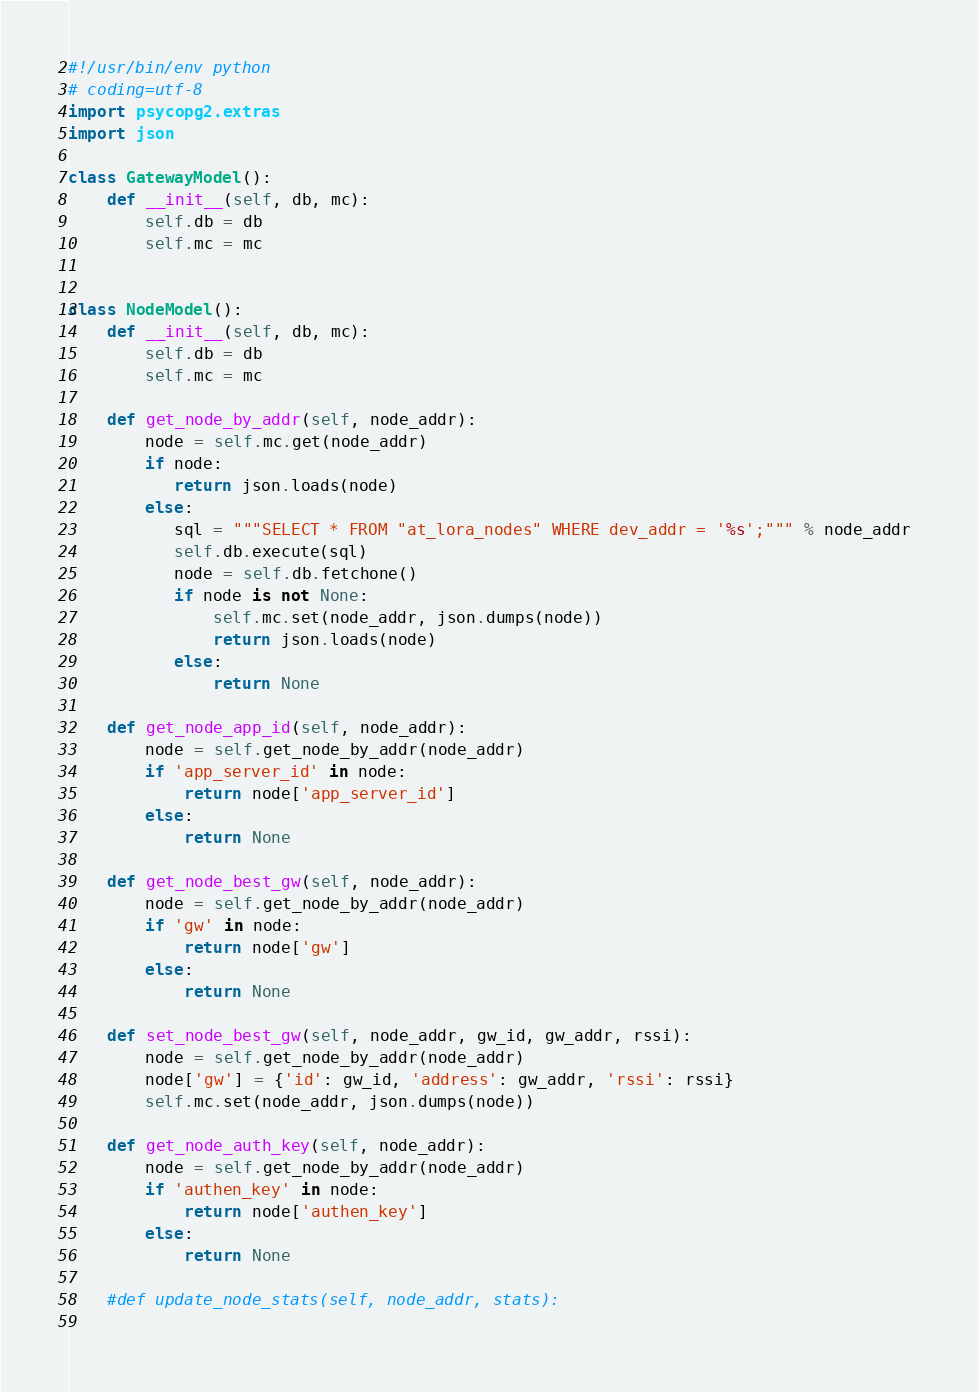Convert code to text. <code><loc_0><loc_0><loc_500><loc_500><_Cython_>#!/usr/bin/env python
# coding=utf-8
import psycopg2.extras
import json

class GatewayModel():
    def __init__(self, db, mc):
        self.db = db
        self.mc = mc


class NodeModel():
    def __init__(self, db, mc):
        self.db = db
        self.mc = mc

    def get_node_by_addr(self, node_addr):
        node = self.mc.get(node_addr)
        if node:
           return json.loads(node)
        else:
           sql = """SELECT * FROM "at_lora_nodes" WHERE dev_addr = '%s';""" % node_addr 
           self.db.execute(sql)
           node = self.db.fetchone()
           if node is not None:
               self.mc.set(node_addr, json.dumps(node))
               return json.loads(node)
           else:
               return None
        
    def get_node_app_id(self, node_addr):
        node = self.get_node_by_addr(node_addr)
        if 'app_server_id' in node:
            return node['app_server_id']
        else:
            return None

    def get_node_best_gw(self, node_addr):
        node = self.get_node_by_addr(node_addr)
        if 'gw' in node:
            return node['gw']
        else:
            return None

    def set_node_best_gw(self, node_addr, gw_id, gw_addr, rssi):
        node = self.get_node_by_addr(node_addr)
        node['gw'] = {'id': gw_id, 'address': gw_addr, 'rssi': rssi}
        self.mc.set(node_addr, json.dumps(node)) 

    def get_node_auth_key(self, node_addr):
        node = self.get_node_by_addr(node_addr)
        if 'authen_key' in node:
            return node['authen_key']
        else:
            return None

    #def update_node_stats(self, node_addr, stats):
        

</code> 